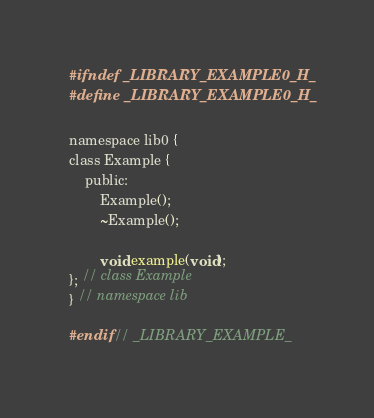<code> <loc_0><loc_0><loc_500><loc_500><_C_>#ifndef _LIBRARY_EXAMPLE0_H_
#define _LIBRARY_EXAMPLE0_H_

namespace lib0 {
class Example {
    public:
        Example();
        ~Example();

        void example(void);
}; // class Example
} // namespace lib

#endif // _LIBRARY_EXAMPLE_</code> 